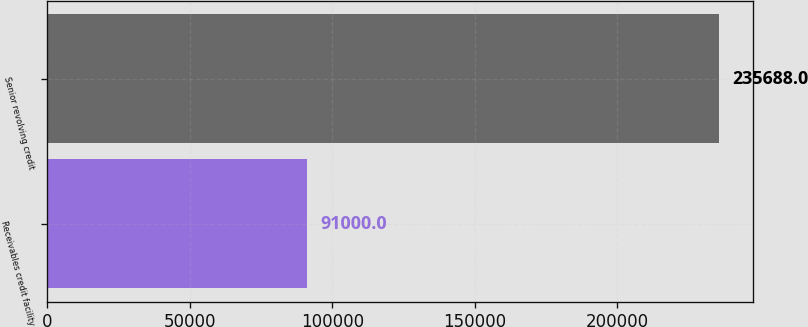<chart> <loc_0><loc_0><loc_500><loc_500><bar_chart><fcel>Receivables credit facility<fcel>Senior revolving credit<nl><fcel>91000<fcel>235688<nl></chart> 